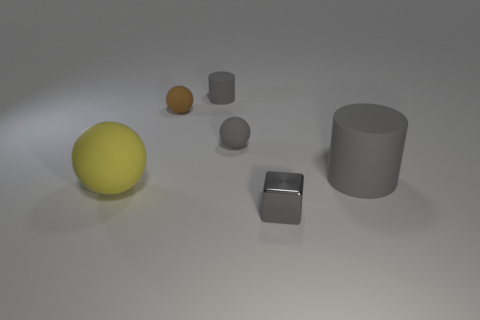There is a gray metallic object that is the same size as the brown rubber sphere; what shape is it?
Ensure brevity in your answer.  Cube. Are there any metallic objects behind the tiny brown matte thing?
Provide a short and direct response. No. Do the gray object that is left of the small gray ball and the tiny ball that is on the left side of the tiny gray rubber cylinder have the same material?
Provide a short and direct response. Yes. What number of metallic things are the same size as the brown matte sphere?
Offer a terse response. 1. What shape is the shiny thing that is the same color as the tiny matte cylinder?
Ensure brevity in your answer.  Cube. What material is the gray cylinder that is behind the big cylinder?
Your response must be concise. Rubber. What number of other large gray objects have the same shape as the shiny thing?
Make the answer very short. 0. What is the shape of the brown object that is the same material as the large yellow sphere?
Offer a terse response. Sphere. There is a gray thing in front of the big rubber thing that is on the left side of the gray cylinder right of the gray block; what is its shape?
Offer a terse response. Cube. Are there more brown objects than green cylinders?
Your response must be concise. Yes. 